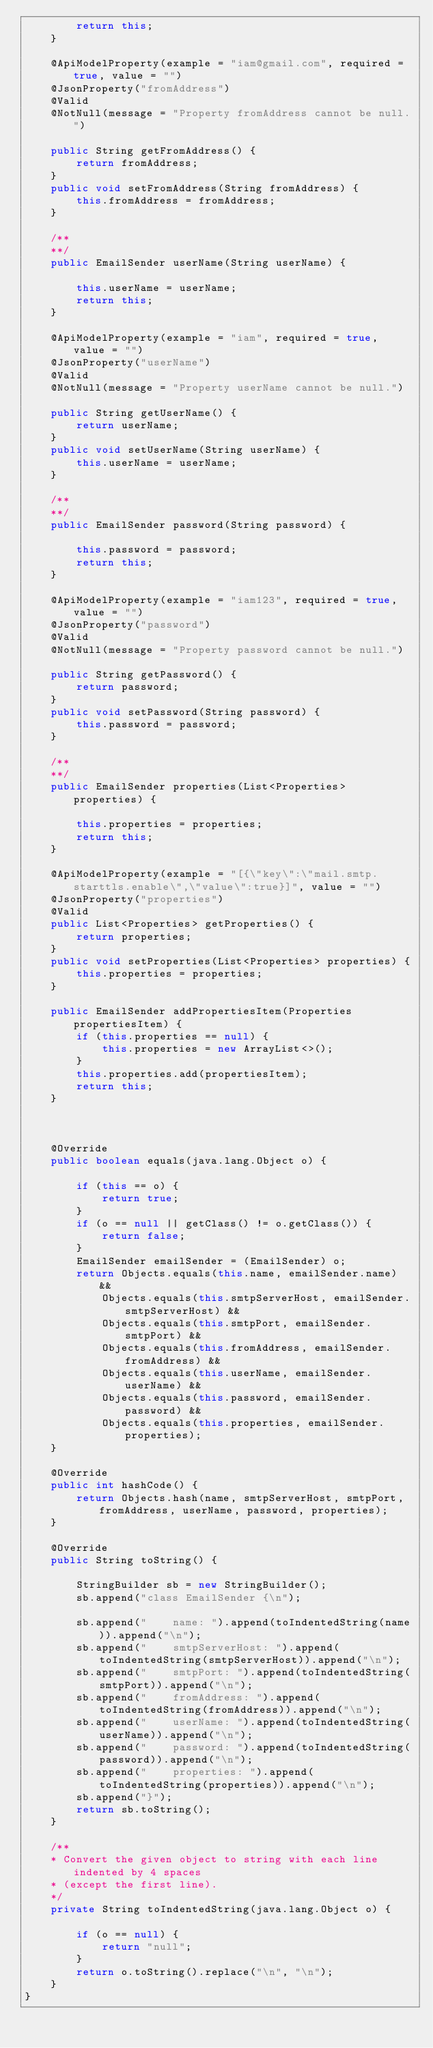Convert code to text. <code><loc_0><loc_0><loc_500><loc_500><_Java_>        return this;
    }
    
    @ApiModelProperty(example = "iam@gmail.com", required = true, value = "")
    @JsonProperty("fromAddress")
    @Valid
    @NotNull(message = "Property fromAddress cannot be null.")

    public String getFromAddress() {
        return fromAddress;
    }
    public void setFromAddress(String fromAddress) {
        this.fromAddress = fromAddress;
    }

    /**
    **/
    public EmailSender userName(String userName) {

        this.userName = userName;
        return this;
    }
    
    @ApiModelProperty(example = "iam", required = true, value = "")
    @JsonProperty("userName")
    @Valid
    @NotNull(message = "Property userName cannot be null.")

    public String getUserName() {
        return userName;
    }
    public void setUserName(String userName) {
        this.userName = userName;
    }

    /**
    **/
    public EmailSender password(String password) {

        this.password = password;
        return this;
    }
    
    @ApiModelProperty(example = "iam123", required = true, value = "")
    @JsonProperty("password")
    @Valid
    @NotNull(message = "Property password cannot be null.")

    public String getPassword() {
        return password;
    }
    public void setPassword(String password) {
        this.password = password;
    }

    /**
    **/
    public EmailSender properties(List<Properties> properties) {

        this.properties = properties;
        return this;
    }
    
    @ApiModelProperty(example = "[{\"key\":\"mail.smtp.starttls.enable\",\"value\":true}]", value = "")
    @JsonProperty("properties")
    @Valid
    public List<Properties> getProperties() {
        return properties;
    }
    public void setProperties(List<Properties> properties) {
        this.properties = properties;
    }

    public EmailSender addPropertiesItem(Properties propertiesItem) {
        if (this.properties == null) {
            this.properties = new ArrayList<>();
        }
        this.properties.add(propertiesItem);
        return this;
    }

    

    @Override
    public boolean equals(java.lang.Object o) {

        if (this == o) {
            return true;
        }
        if (o == null || getClass() != o.getClass()) {
            return false;
        }
        EmailSender emailSender = (EmailSender) o;
        return Objects.equals(this.name, emailSender.name) &&
            Objects.equals(this.smtpServerHost, emailSender.smtpServerHost) &&
            Objects.equals(this.smtpPort, emailSender.smtpPort) &&
            Objects.equals(this.fromAddress, emailSender.fromAddress) &&
            Objects.equals(this.userName, emailSender.userName) &&
            Objects.equals(this.password, emailSender.password) &&
            Objects.equals(this.properties, emailSender.properties);
    }

    @Override
    public int hashCode() {
        return Objects.hash(name, smtpServerHost, smtpPort, fromAddress, userName, password, properties);
    }

    @Override
    public String toString() {

        StringBuilder sb = new StringBuilder();
        sb.append("class EmailSender {\n");
        
        sb.append("    name: ").append(toIndentedString(name)).append("\n");
        sb.append("    smtpServerHost: ").append(toIndentedString(smtpServerHost)).append("\n");
        sb.append("    smtpPort: ").append(toIndentedString(smtpPort)).append("\n");
        sb.append("    fromAddress: ").append(toIndentedString(fromAddress)).append("\n");
        sb.append("    userName: ").append(toIndentedString(userName)).append("\n");
        sb.append("    password: ").append(toIndentedString(password)).append("\n");
        sb.append("    properties: ").append(toIndentedString(properties)).append("\n");
        sb.append("}");
        return sb.toString();
    }

    /**
    * Convert the given object to string with each line indented by 4 spaces
    * (except the first line).
    */
    private String toIndentedString(java.lang.Object o) {

        if (o == null) {
            return "null";
        }
        return o.toString().replace("\n", "\n");
    }
}

</code> 